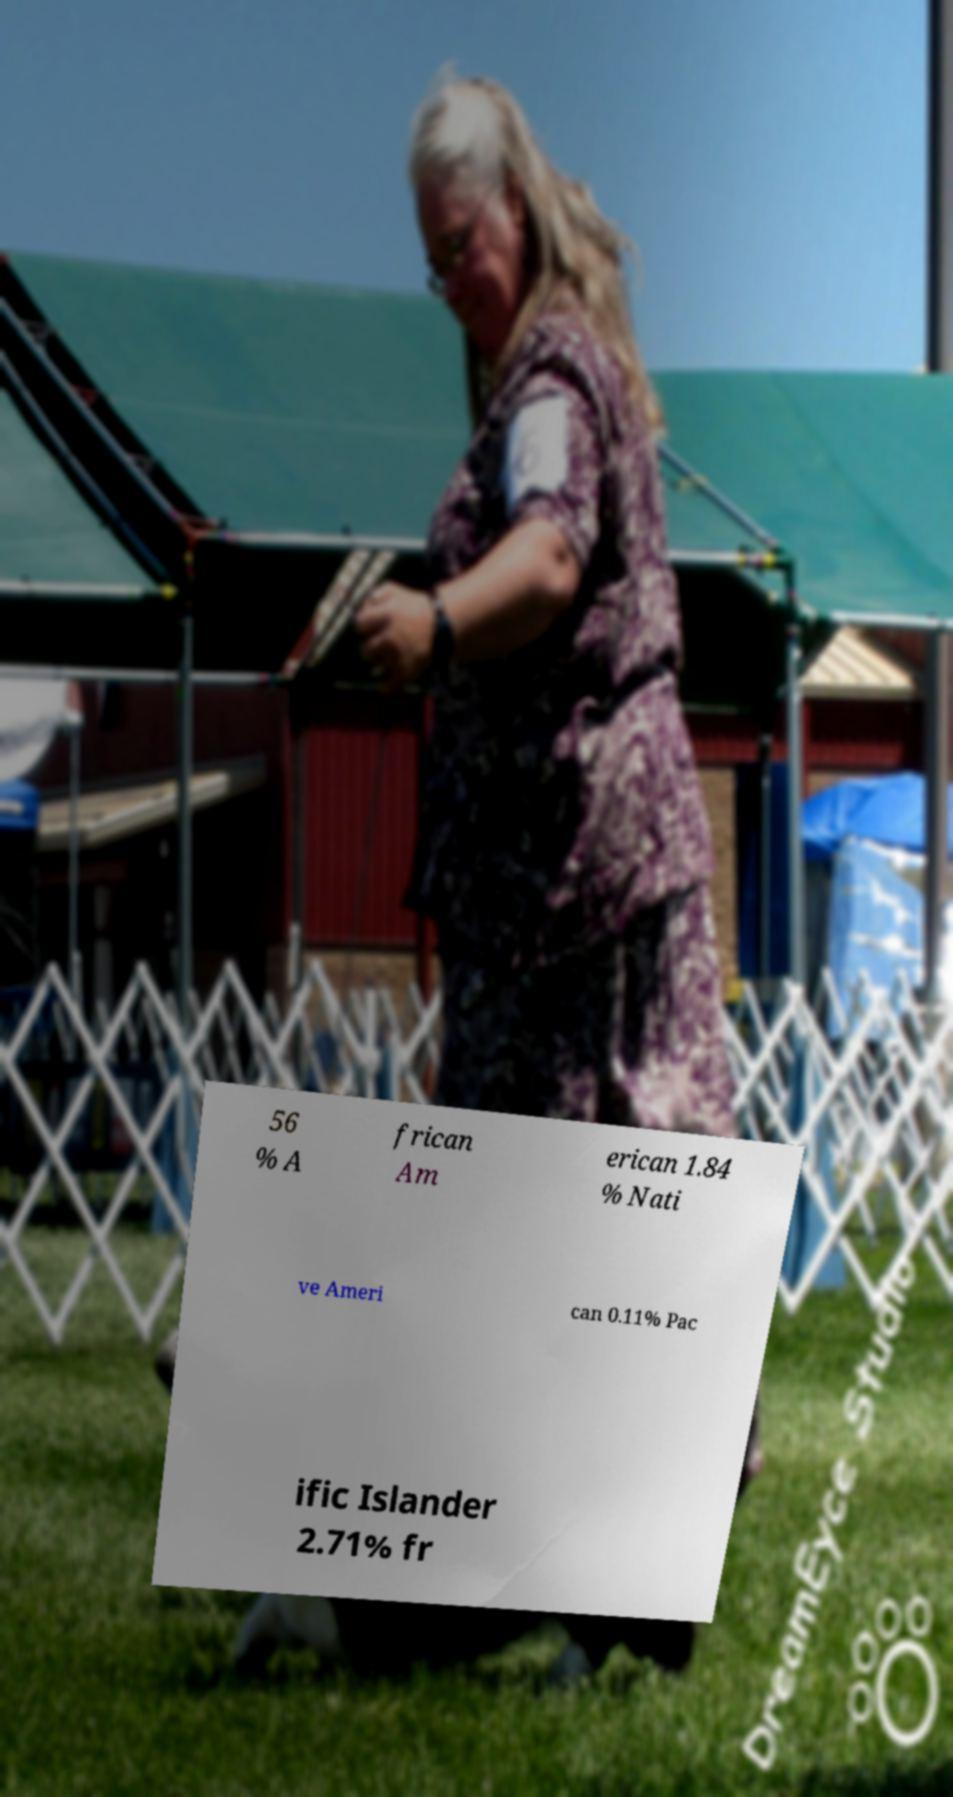Please read and relay the text visible in this image. What does it say? 56 % A frican Am erican 1.84 % Nati ve Ameri can 0.11% Pac ific Islander 2.71% fr 